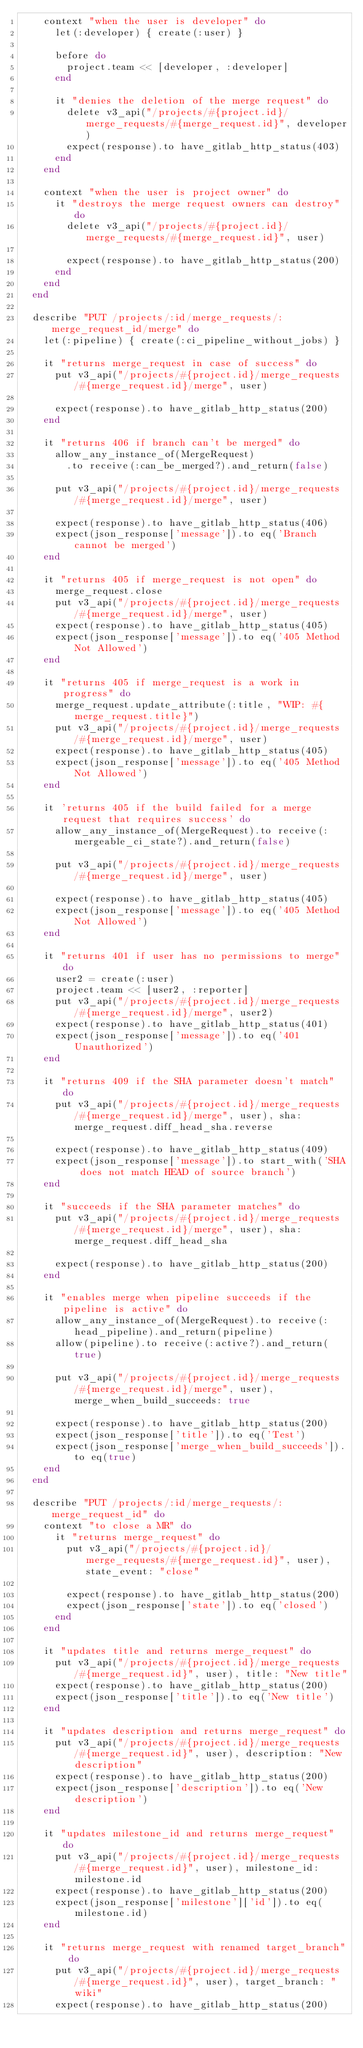Convert code to text. <code><loc_0><loc_0><loc_500><loc_500><_Ruby_>    context "when the user is developer" do
      let(:developer) { create(:user) }

      before do
        project.team << [developer, :developer]
      end

      it "denies the deletion of the merge request" do
        delete v3_api("/projects/#{project.id}/merge_requests/#{merge_request.id}", developer)
        expect(response).to have_gitlab_http_status(403)
      end
    end

    context "when the user is project owner" do
      it "destroys the merge request owners can destroy" do
        delete v3_api("/projects/#{project.id}/merge_requests/#{merge_request.id}", user)

        expect(response).to have_gitlab_http_status(200)
      end
    end
  end

  describe "PUT /projects/:id/merge_requests/:merge_request_id/merge" do
    let(:pipeline) { create(:ci_pipeline_without_jobs) }

    it "returns merge_request in case of success" do
      put v3_api("/projects/#{project.id}/merge_requests/#{merge_request.id}/merge", user)

      expect(response).to have_gitlab_http_status(200)
    end

    it "returns 406 if branch can't be merged" do
      allow_any_instance_of(MergeRequest)
        .to receive(:can_be_merged?).and_return(false)

      put v3_api("/projects/#{project.id}/merge_requests/#{merge_request.id}/merge", user)

      expect(response).to have_gitlab_http_status(406)
      expect(json_response['message']).to eq('Branch cannot be merged')
    end

    it "returns 405 if merge_request is not open" do
      merge_request.close
      put v3_api("/projects/#{project.id}/merge_requests/#{merge_request.id}/merge", user)
      expect(response).to have_gitlab_http_status(405)
      expect(json_response['message']).to eq('405 Method Not Allowed')
    end

    it "returns 405 if merge_request is a work in progress" do
      merge_request.update_attribute(:title, "WIP: #{merge_request.title}")
      put v3_api("/projects/#{project.id}/merge_requests/#{merge_request.id}/merge", user)
      expect(response).to have_gitlab_http_status(405)
      expect(json_response['message']).to eq('405 Method Not Allowed')
    end

    it 'returns 405 if the build failed for a merge request that requires success' do
      allow_any_instance_of(MergeRequest).to receive(:mergeable_ci_state?).and_return(false)

      put v3_api("/projects/#{project.id}/merge_requests/#{merge_request.id}/merge", user)

      expect(response).to have_gitlab_http_status(405)
      expect(json_response['message']).to eq('405 Method Not Allowed')
    end

    it "returns 401 if user has no permissions to merge" do
      user2 = create(:user)
      project.team << [user2, :reporter]
      put v3_api("/projects/#{project.id}/merge_requests/#{merge_request.id}/merge", user2)
      expect(response).to have_gitlab_http_status(401)
      expect(json_response['message']).to eq('401 Unauthorized')
    end

    it "returns 409 if the SHA parameter doesn't match" do
      put v3_api("/projects/#{project.id}/merge_requests/#{merge_request.id}/merge", user), sha: merge_request.diff_head_sha.reverse

      expect(response).to have_gitlab_http_status(409)
      expect(json_response['message']).to start_with('SHA does not match HEAD of source branch')
    end

    it "succeeds if the SHA parameter matches" do
      put v3_api("/projects/#{project.id}/merge_requests/#{merge_request.id}/merge", user), sha: merge_request.diff_head_sha

      expect(response).to have_gitlab_http_status(200)
    end

    it "enables merge when pipeline succeeds if the pipeline is active" do
      allow_any_instance_of(MergeRequest).to receive(:head_pipeline).and_return(pipeline)
      allow(pipeline).to receive(:active?).and_return(true)

      put v3_api("/projects/#{project.id}/merge_requests/#{merge_request.id}/merge", user), merge_when_build_succeeds: true

      expect(response).to have_gitlab_http_status(200)
      expect(json_response['title']).to eq('Test')
      expect(json_response['merge_when_build_succeeds']).to eq(true)
    end
  end

  describe "PUT /projects/:id/merge_requests/:merge_request_id" do
    context "to close a MR" do
      it "returns merge_request" do
        put v3_api("/projects/#{project.id}/merge_requests/#{merge_request.id}", user), state_event: "close"

        expect(response).to have_gitlab_http_status(200)
        expect(json_response['state']).to eq('closed')
      end
    end

    it "updates title and returns merge_request" do
      put v3_api("/projects/#{project.id}/merge_requests/#{merge_request.id}", user), title: "New title"
      expect(response).to have_gitlab_http_status(200)
      expect(json_response['title']).to eq('New title')
    end

    it "updates description and returns merge_request" do
      put v3_api("/projects/#{project.id}/merge_requests/#{merge_request.id}", user), description: "New description"
      expect(response).to have_gitlab_http_status(200)
      expect(json_response['description']).to eq('New description')
    end

    it "updates milestone_id and returns merge_request" do
      put v3_api("/projects/#{project.id}/merge_requests/#{merge_request.id}", user), milestone_id: milestone.id
      expect(response).to have_gitlab_http_status(200)
      expect(json_response['milestone']['id']).to eq(milestone.id)
    end

    it "returns merge_request with renamed target_branch" do
      put v3_api("/projects/#{project.id}/merge_requests/#{merge_request.id}", user), target_branch: "wiki"
      expect(response).to have_gitlab_http_status(200)</code> 